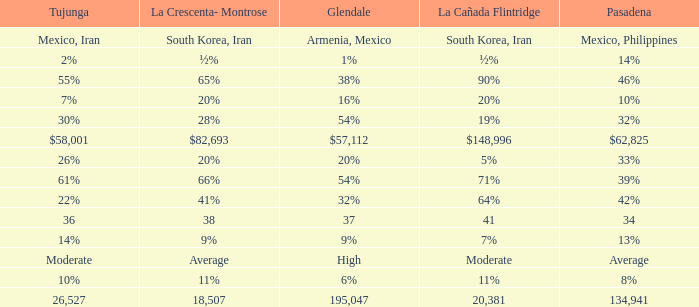What is the percentage of La Canada Flintridge when Tujunga is 7%? 20%. 